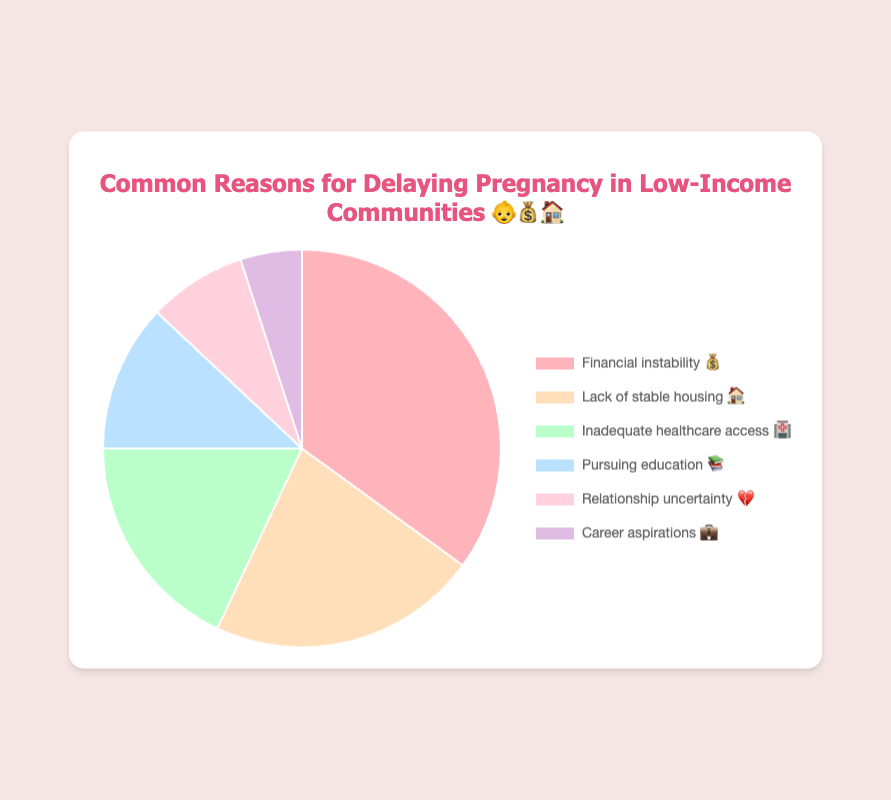What is the most common reason for delaying pregnancy in low-income communities? The most common reason can be identified by finding the data point with the highest percentage in the chart. Financial instability has the highest percentage of 35%.
Answer: Financial instability What percentage of people delay pregnancy due to lack of stable housing? Find the data point labeled "Lack of stable housing 🏠" on the chart and read the associated percentage.
Answer: 22% How much higher is the percentage of people delaying pregnancy due to financial instability compared to those delaying due to career aspirations? Subtract the percentage for career aspirations (5%) from the percentage for financial instability (35%). 35% - 5% = 30%.
Answer: 30% What's the combined percentage of people delaying pregnancy due to inadequate healthcare access and pursuing education? Add the percentages for "Inadequate healthcare access 🏥" (18%) and "Pursuing education 📚" (12%). 18% + 12% = 30%.
Answer: 30% How does the percentage of people delaying pregnancy due to relationship uncertainty compare to those delaying due to pursuing education? Compare the percentages for "Relationship uncertainty 💔" (8%) and "Pursuing education 📚" (12%). 8% is less than 12%.
Answer: Less What is the total percentage of people delaying pregnancy for reasons other than financial instability? Add the percentages of all reasons except "Financial instability 💰". 22% + 18% + 12% + 8% + 5% = 65%.
Answer: 65% Which two reasons for delaying pregnancy have the smallest percentage difference between them? Compare the differences between each pair of reasons and identify the smallest difference. The smallest difference is between "Relationship uncertainty 💔" (8%) and "Career aspirations 💼" (5%), which is 3%.
Answer: Relationship uncertainty and Career aspirations Which portion of the pie chart is the largest? The largest portion corresponds to the data point with the highest percentage. Financial instability has the highest percentage of 35%.
Answer: Financial instability How many reasons are represented in the chart? Count the number of distinct labels in the chart. There are six reasons in total.
Answer: Six 